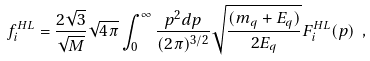Convert formula to latex. <formula><loc_0><loc_0><loc_500><loc_500>f _ { i } ^ { H L } = \frac { 2 \sqrt { 3 } } { \sqrt { M } } \sqrt { 4 \pi } \int _ { 0 } ^ { \infty } \frac { p ^ { 2 } d p } { ( 2 \pi ) ^ { 3 / 2 } } \sqrt { \frac { ( m _ { q } + E _ { q } ) } { 2 E _ { q } } } F _ { i } ^ { H L } ( p ) \ ,</formula> 